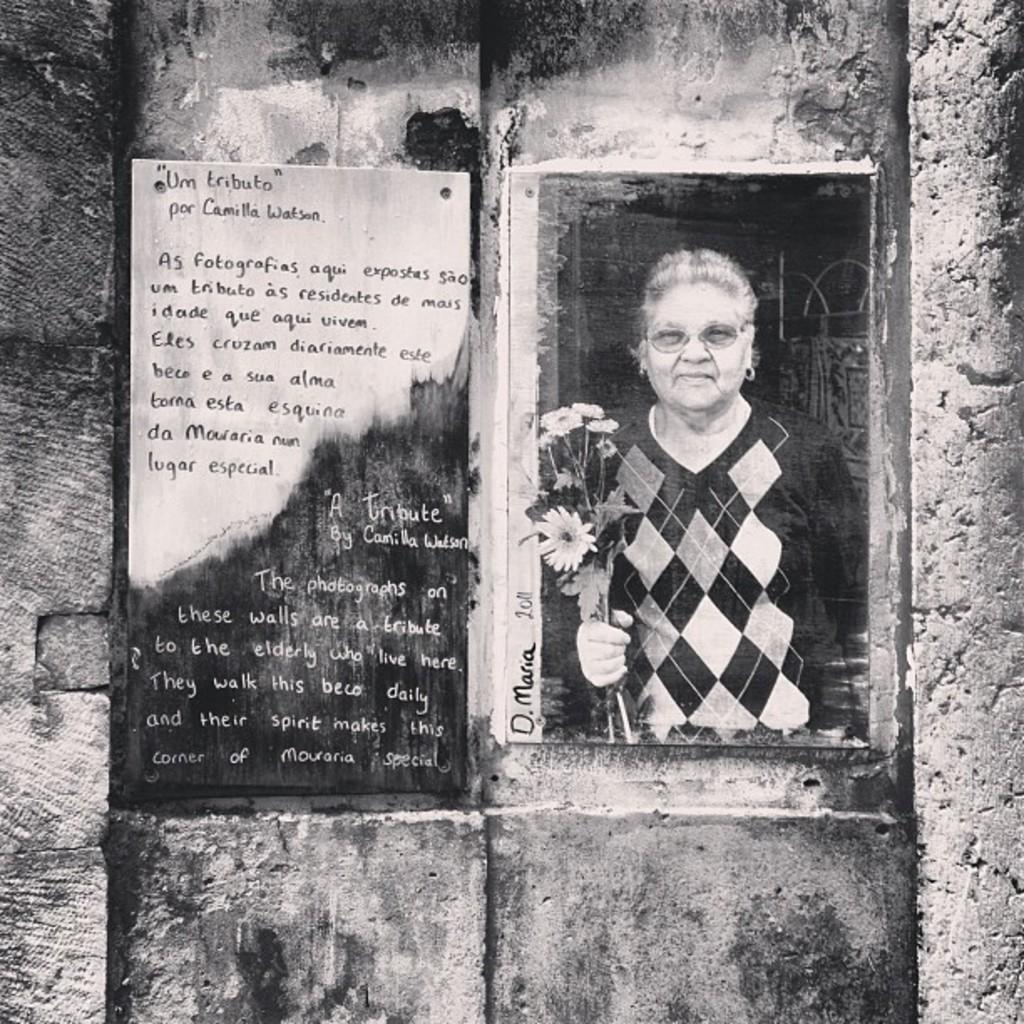What can be seen on the wall in the image? There are borders and frames on the wall in the image. Are there any specific details on the boards? Yes, there is text on one of the boards, and there is a person holding flowers on another board. Reasoning: Let' Let's think step by step in order to produce the conversation. We start by identifying the main subject in the image, which is the borders and frames on the wall. Then, we expand the conversation to include specific details about the boards, such as the presence of text and a person holding flowers. Each question is designed to elicit a specific detail about the image that is known from the provided facts. Absurd Question/Answer: What type of alley can be seen behind the person holding flowers in the image? There is no alley present in the image; it features borders and frames on a wall with text and a person holding flowers. Can you tell me how many wrenches are being used by the person holding flowers in the image? There are no wrenches present in the image; it features borders and frames on a wall with text and a person holding flowers. 